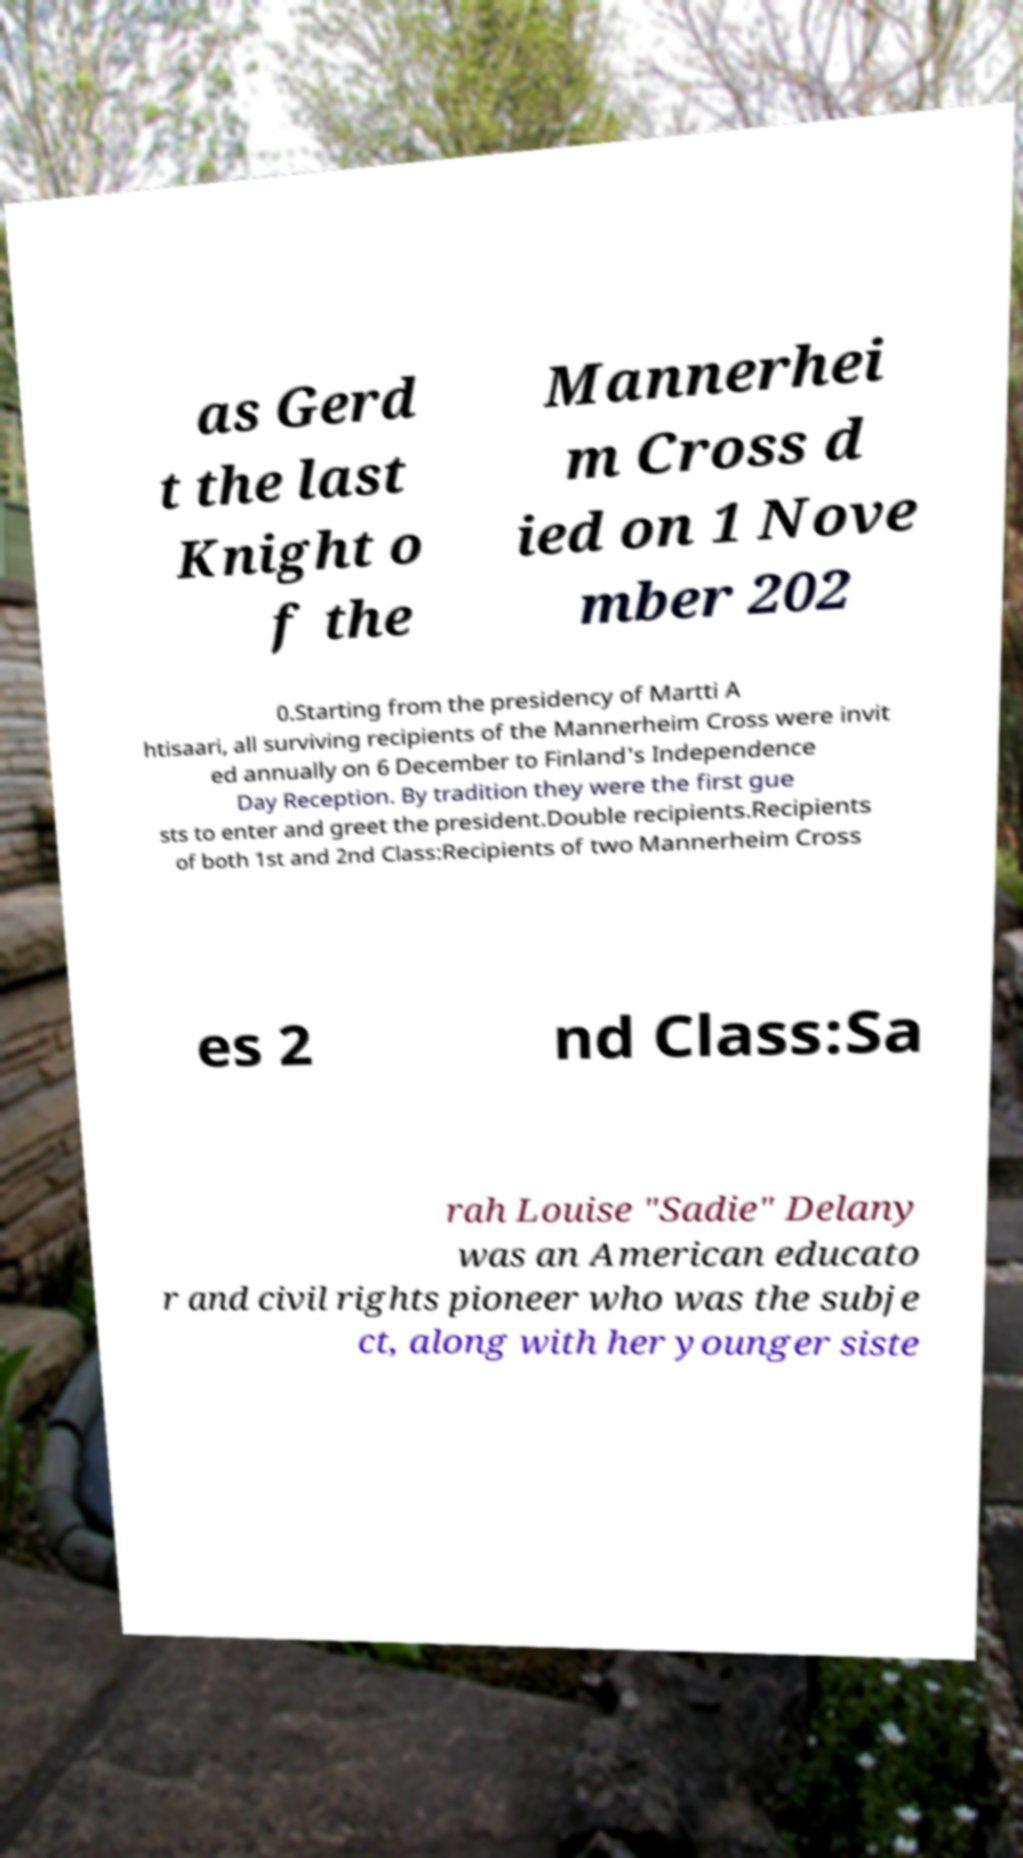Can you accurately transcribe the text from the provided image for me? as Gerd t the last Knight o f the Mannerhei m Cross d ied on 1 Nove mber 202 0.Starting from the presidency of Martti A htisaari, all surviving recipients of the Mannerheim Cross were invit ed annually on 6 December to Finland's Independence Day Reception. By tradition they were the first gue sts to enter and greet the president.Double recipients.Recipients of both 1st and 2nd Class:Recipients of two Mannerheim Cross es 2 nd Class:Sa rah Louise "Sadie" Delany was an American educato r and civil rights pioneer who was the subje ct, along with her younger siste 